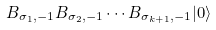<formula> <loc_0><loc_0><loc_500><loc_500>B _ { \sigma _ { 1 } , - 1 } B _ { \sigma _ { 2 } , - 1 } \cdots B _ { \sigma _ { k + 1 } , - 1 } | 0 \rangle</formula> 